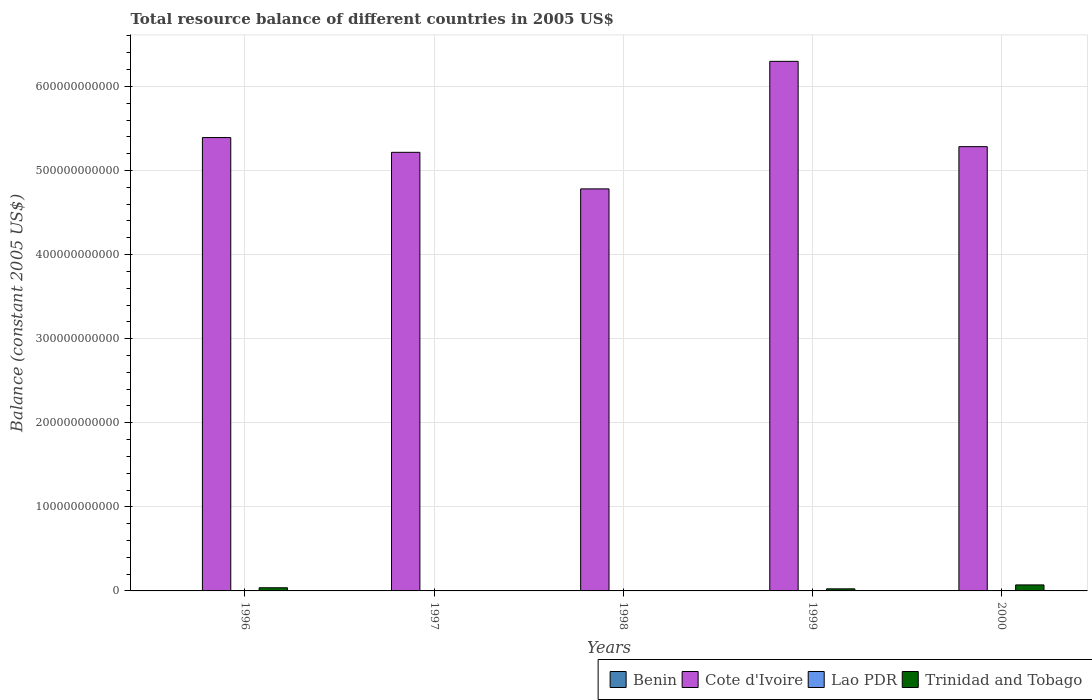Are the number of bars per tick equal to the number of legend labels?
Provide a succinct answer. No. How many bars are there on the 5th tick from the left?
Ensure brevity in your answer.  2. How many bars are there on the 4th tick from the right?
Offer a very short reply. 1. In how many cases, is the number of bars for a given year not equal to the number of legend labels?
Your answer should be very brief. 5. Across all years, what is the maximum total resource balance in Trinidad and Tobago?
Keep it short and to the point. 7.15e+09. Across all years, what is the minimum total resource balance in Benin?
Keep it short and to the point. 0. What is the difference between the total resource balance in Cote d'Ivoire in 1997 and that in 1998?
Ensure brevity in your answer.  4.35e+1. What is the difference between the total resource balance in Lao PDR in 2000 and the total resource balance in Trinidad and Tobago in 1996?
Ensure brevity in your answer.  -3.76e+09. What is the average total resource balance in Trinidad and Tobago per year?
Ensure brevity in your answer.  2.68e+09. In the year 1996, what is the difference between the total resource balance in Trinidad and Tobago and total resource balance in Cote d'Ivoire?
Your response must be concise. -5.35e+11. In how many years, is the total resource balance in Trinidad and Tobago greater than 380000000000 US$?
Ensure brevity in your answer.  0. What is the difference between the highest and the second highest total resource balance in Trinidad and Tobago?
Your answer should be very brief. 3.39e+09. What is the difference between the highest and the lowest total resource balance in Cote d'Ivoire?
Ensure brevity in your answer.  1.52e+11. In how many years, is the total resource balance in Cote d'Ivoire greater than the average total resource balance in Cote d'Ivoire taken over all years?
Give a very brief answer. 1. Is it the case that in every year, the sum of the total resource balance in Cote d'Ivoire and total resource balance in Trinidad and Tobago is greater than the sum of total resource balance in Lao PDR and total resource balance in Benin?
Keep it short and to the point. No. Is it the case that in every year, the sum of the total resource balance in Benin and total resource balance in Cote d'Ivoire is greater than the total resource balance in Lao PDR?
Keep it short and to the point. Yes. What is the difference between two consecutive major ticks on the Y-axis?
Offer a very short reply. 1.00e+11. Are the values on the major ticks of Y-axis written in scientific E-notation?
Your answer should be compact. No. Does the graph contain any zero values?
Your answer should be very brief. Yes. Does the graph contain grids?
Make the answer very short. Yes. What is the title of the graph?
Your answer should be very brief. Total resource balance of different countries in 2005 US$. What is the label or title of the X-axis?
Give a very brief answer. Years. What is the label or title of the Y-axis?
Make the answer very short. Balance (constant 2005 US$). What is the Balance (constant 2005 US$) in Cote d'Ivoire in 1996?
Provide a succinct answer. 5.39e+11. What is the Balance (constant 2005 US$) in Trinidad and Tobago in 1996?
Your response must be concise. 3.76e+09. What is the Balance (constant 2005 US$) of Benin in 1997?
Give a very brief answer. 0. What is the Balance (constant 2005 US$) in Cote d'Ivoire in 1997?
Keep it short and to the point. 5.22e+11. What is the Balance (constant 2005 US$) in Lao PDR in 1997?
Your answer should be very brief. 0. What is the Balance (constant 2005 US$) of Trinidad and Tobago in 1997?
Provide a succinct answer. 0. What is the Balance (constant 2005 US$) in Cote d'Ivoire in 1998?
Your response must be concise. 4.78e+11. What is the Balance (constant 2005 US$) of Lao PDR in 1998?
Your response must be concise. 0. What is the Balance (constant 2005 US$) in Trinidad and Tobago in 1998?
Provide a succinct answer. 0. What is the Balance (constant 2005 US$) of Benin in 1999?
Your answer should be very brief. 0. What is the Balance (constant 2005 US$) in Cote d'Ivoire in 1999?
Make the answer very short. 6.30e+11. What is the Balance (constant 2005 US$) in Trinidad and Tobago in 1999?
Give a very brief answer. 2.47e+09. What is the Balance (constant 2005 US$) in Benin in 2000?
Your answer should be very brief. 0. What is the Balance (constant 2005 US$) in Cote d'Ivoire in 2000?
Provide a succinct answer. 5.28e+11. What is the Balance (constant 2005 US$) of Trinidad and Tobago in 2000?
Ensure brevity in your answer.  7.15e+09. Across all years, what is the maximum Balance (constant 2005 US$) of Cote d'Ivoire?
Ensure brevity in your answer.  6.30e+11. Across all years, what is the maximum Balance (constant 2005 US$) of Trinidad and Tobago?
Offer a terse response. 7.15e+09. Across all years, what is the minimum Balance (constant 2005 US$) of Cote d'Ivoire?
Your response must be concise. 4.78e+11. Across all years, what is the minimum Balance (constant 2005 US$) in Trinidad and Tobago?
Provide a short and direct response. 0. What is the total Balance (constant 2005 US$) of Benin in the graph?
Offer a very short reply. 0. What is the total Balance (constant 2005 US$) in Cote d'Ivoire in the graph?
Your answer should be very brief. 2.70e+12. What is the total Balance (constant 2005 US$) in Trinidad and Tobago in the graph?
Give a very brief answer. 1.34e+1. What is the difference between the Balance (constant 2005 US$) in Cote d'Ivoire in 1996 and that in 1997?
Keep it short and to the point. 1.76e+1. What is the difference between the Balance (constant 2005 US$) of Cote d'Ivoire in 1996 and that in 1998?
Offer a terse response. 6.10e+1. What is the difference between the Balance (constant 2005 US$) in Cote d'Ivoire in 1996 and that in 1999?
Keep it short and to the point. -9.06e+1. What is the difference between the Balance (constant 2005 US$) in Trinidad and Tobago in 1996 and that in 1999?
Provide a succinct answer. 1.29e+09. What is the difference between the Balance (constant 2005 US$) in Cote d'Ivoire in 1996 and that in 2000?
Your answer should be compact. 1.08e+1. What is the difference between the Balance (constant 2005 US$) in Trinidad and Tobago in 1996 and that in 2000?
Offer a very short reply. -3.39e+09. What is the difference between the Balance (constant 2005 US$) of Cote d'Ivoire in 1997 and that in 1998?
Give a very brief answer. 4.35e+1. What is the difference between the Balance (constant 2005 US$) in Cote d'Ivoire in 1997 and that in 1999?
Make the answer very short. -1.08e+11. What is the difference between the Balance (constant 2005 US$) of Cote d'Ivoire in 1997 and that in 2000?
Provide a short and direct response. -6.72e+09. What is the difference between the Balance (constant 2005 US$) in Cote d'Ivoire in 1998 and that in 1999?
Provide a succinct answer. -1.52e+11. What is the difference between the Balance (constant 2005 US$) in Cote d'Ivoire in 1998 and that in 2000?
Provide a short and direct response. -5.02e+1. What is the difference between the Balance (constant 2005 US$) in Cote d'Ivoire in 1999 and that in 2000?
Your response must be concise. 1.01e+11. What is the difference between the Balance (constant 2005 US$) of Trinidad and Tobago in 1999 and that in 2000?
Offer a very short reply. -4.68e+09. What is the difference between the Balance (constant 2005 US$) in Cote d'Ivoire in 1996 and the Balance (constant 2005 US$) in Trinidad and Tobago in 1999?
Offer a terse response. 5.37e+11. What is the difference between the Balance (constant 2005 US$) in Cote d'Ivoire in 1996 and the Balance (constant 2005 US$) in Trinidad and Tobago in 2000?
Your response must be concise. 5.32e+11. What is the difference between the Balance (constant 2005 US$) of Cote d'Ivoire in 1997 and the Balance (constant 2005 US$) of Trinidad and Tobago in 1999?
Your answer should be compact. 5.19e+11. What is the difference between the Balance (constant 2005 US$) of Cote d'Ivoire in 1997 and the Balance (constant 2005 US$) of Trinidad and Tobago in 2000?
Give a very brief answer. 5.14e+11. What is the difference between the Balance (constant 2005 US$) of Cote d'Ivoire in 1998 and the Balance (constant 2005 US$) of Trinidad and Tobago in 1999?
Offer a terse response. 4.76e+11. What is the difference between the Balance (constant 2005 US$) in Cote d'Ivoire in 1998 and the Balance (constant 2005 US$) in Trinidad and Tobago in 2000?
Keep it short and to the point. 4.71e+11. What is the difference between the Balance (constant 2005 US$) in Cote d'Ivoire in 1999 and the Balance (constant 2005 US$) in Trinidad and Tobago in 2000?
Provide a short and direct response. 6.23e+11. What is the average Balance (constant 2005 US$) of Cote d'Ivoire per year?
Your answer should be very brief. 5.39e+11. What is the average Balance (constant 2005 US$) in Lao PDR per year?
Ensure brevity in your answer.  0. What is the average Balance (constant 2005 US$) in Trinidad and Tobago per year?
Your answer should be compact. 2.68e+09. In the year 1996, what is the difference between the Balance (constant 2005 US$) in Cote d'Ivoire and Balance (constant 2005 US$) in Trinidad and Tobago?
Offer a terse response. 5.35e+11. In the year 1999, what is the difference between the Balance (constant 2005 US$) in Cote d'Ivoire and Balance (constant 2005 US$) in Trinidad and Tobago?
Your answer should be compact. 6.27e+11. In the year 2000, what is the difference between the Balance (constant 2005 US$) in Cote d'Ivoire and Balance (constant 2005 US$) in Trinidad and Tobago?
Make the answer very short. 5.21e+11. What is the ratio of the Balance (constant 2005 US$) of Cote d'Ivoire in 1996 to that in 1997?
Your answer should be compact. 1.03. What is the ratio of the Balance (constant 2005 US$) of Cote d'Ivoire in 1996 to that in 1998?
Provide a short and direct response. 1.13. What is the ratio of the Balance (constant 2005 US$) in Cote d'Ivoire in 1996 to that in 1999?
Your answer should be compact. 0.86. What is the ratio of the Balance (constant 2005 US$) in Trinidad and Tobago in 1996 to that in 1999?
Offer a very short reply. 1.52. What is the ratio of the Balance (constant 2005 US$) in Cote d'Ivoire in 1996 to that in 2000?
Your response must be concise. 1.02. What is the ratio of the Balance (constant 2005 US$) in Trinidad and Tobago in 1996 to that in 2000?
Provide a succinct answer. 0.53. What is the ratio of the Balance (constant 2005 US$) of Cote d'Ivoire in 1997 to that in 1999?
Provide a succinct answer. 0.83. What is the ratio of the Balance (constant 2005 US$) of Cote d'Ivoire in 1997 to that in 2000?
Provide a succinct answer. 0.99. What is the ratio of the Balance (constant 2005 US$) in Cote d'Ivoire in 1998 to that in 1999?
Offer a very short reply. 0.76. What is the ratio of the Balance (constant 2005 US$) of Cote d'Ivoire in 1998 to that in 2000?
Your answer should be very brief. 0.91. What is the ratio of the Balance (constant 2005 US$) of Cote d'Ivoire in 1999 to that in 2000?
Offer a very short reply. 1.19. What is the ratio of the Balance (constant 2005 US$) of Trinidad and Tobago in 1999 to that in 2000?
Make the answer very short. 0.35. What is the difference between the highest and the second highest Balance (constant 2005 US$) of Cote d'Ivoire?
Provide a short and direct response. 9.06e+1. What is the difference between the highest and the second highest Balance (constant 2005 US$) of Trinidad and Tobago?
Provide a succinct answer. 3.39e+09. What is the difference between the highest and the lowest Balance (constant 2005 US$) of Cote d'Ivoire?
Your answer should be compact. 1.52e+11. What is the difference between the highest and the lowest Balance (constant 2005 US$) in Trinidad and Tobago?
Offer a terse response. 7.15e+09. 